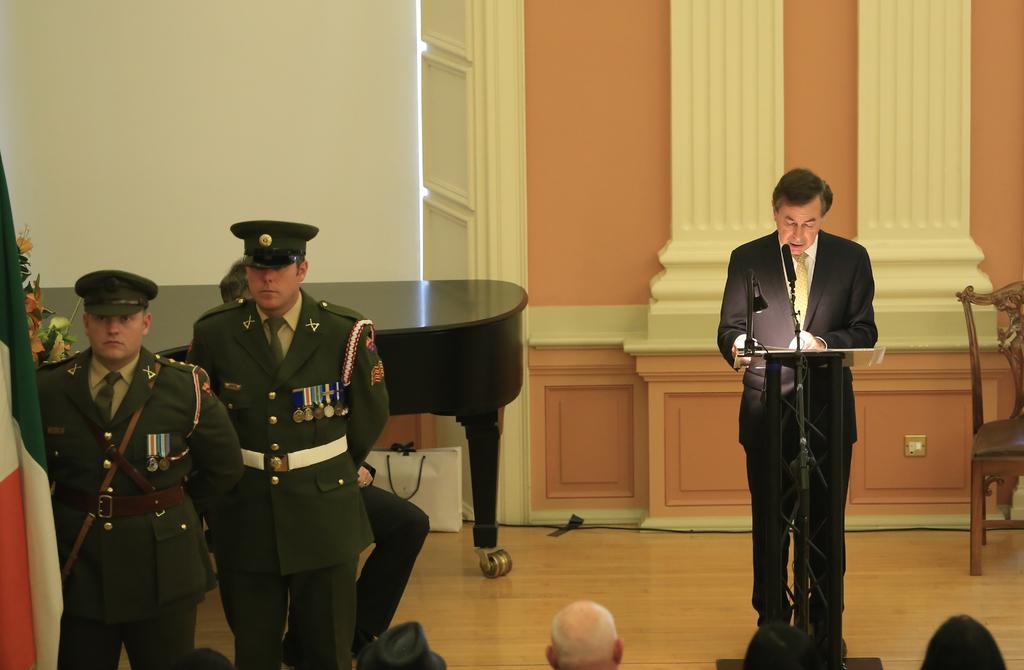Describe this image in one or two sentences. 2 policemen are standing at the left. There is a flag and flower bouquet at the left. A man is standing wearing a suit. There is a microphone and its stand. There is a chair at the back. 